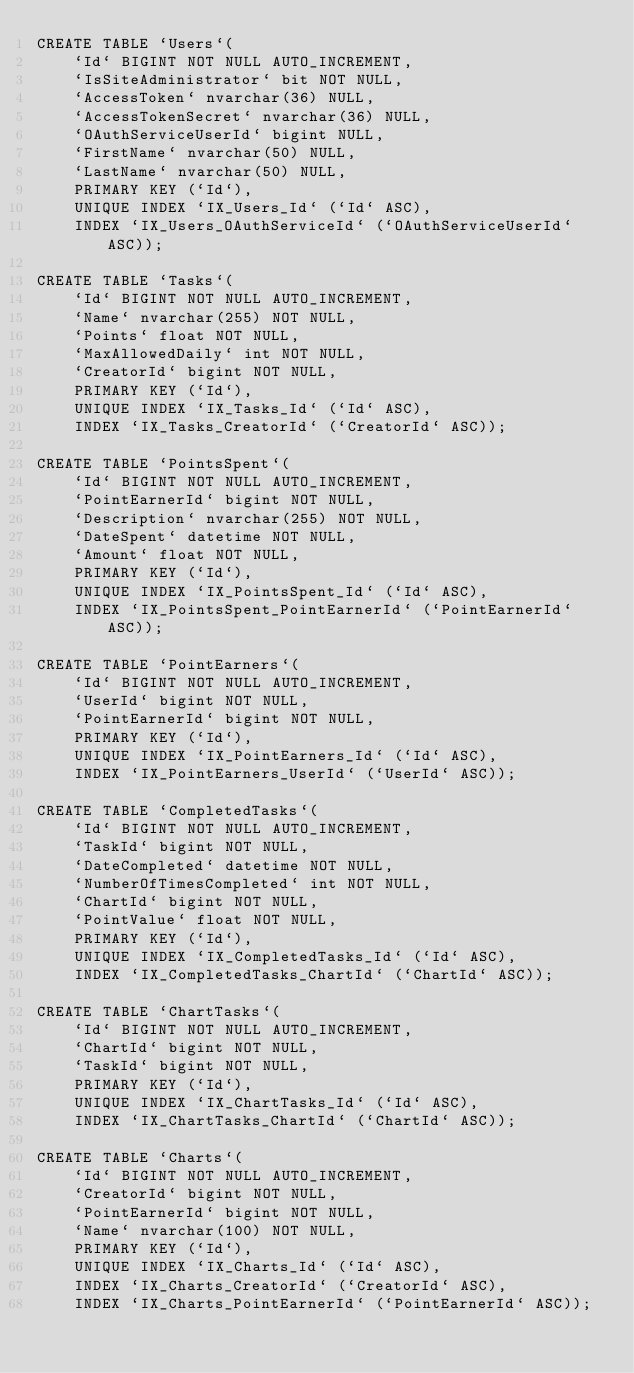<code> <loc_0><loc_0><loc_500><loc_500><_SQL_>CREATE TABLE `Users`(
	`Id` BIGINT NOT NULL AUTO_INCREMENT,
	`IsSiteAdministrator` bit NOT NULL,
	`AccessToken` nvarchar(36) NULL,
	`AccessTokenSecret` nvarchar(36) NULL,
	`OAuthServiceUserId` bigint NULL,
	`FirstName` nvarchar(50) NULL,
	`LastName` nvarchar(50) NULL,
	PRIMARY KEY (`Id`),
	UNIQUE INDEX `IX_Users_Id` (`Id` ASC),
	INDEX `IX_Users_OAuthServiceId` (`OAuthServiceUserId` ASC));

CREATE TABLE `Tasks`(
	`Id` BIGINT NOT NULL AUTO_INCREMENT,
	`Name` nvarchar(255) NOT NULL,
	`Points` float NOT NULL,
	`MaxAllowedDaily` int NOT NULL,
	`CreatorId` bigint NOT NULL,
	PRIMARY KEY (`Id`),
	UNIQUE INDEX `IX_Tasks_Id` (`Id` ASC),
	INDEX `IX_Tasks_CreatorId` (`CreatorId` ASC));

CREATE TABLE `PointsSpent`(
	`Id` BIGINT NOT NULL AUTO_INCREMENT,
	`PointEarnerId` bigint NOT NULL,
	`Description` nvarchar(255) NOT NULL,
	`DateSpent` datetime NOT NULL,
	`Amount` float NOT NULL,
	PRIMARY KEY (`Id`),
	UNIQUE INDEX `IX_PointsSpent_Id` (`Id` ASC),
	INDEX `IX_PointsSpent_PointEarnerId` (`PointEarnerId` ASC));

CREATE TABLE `PointEarners`(
	`Id` BIGINT NOT NULL AUTO_INCREMENT,
	`UserId` bigint NOT NULL,
	`PointEarnerId` bigint NOT NULL,
	PRIMARY KEY (`Id`),
	UNIQUE INDEX `IX_PointEarners_Id` (`Id` ASC),
	INDEX `IX_PointEarners_UserId` (`UserId` ASC));

CREATE TABLE `CompletedTasks`(
	`Id` BIGINT NOT NULL AUTO_INCREMENT,
	`TaskId` bigint NOT NULL,
	`DateCompleted` datetime NOT NULL,
	`NumberOfTimesCompleted` int NOT NULL,
	`ChartId` bigint NOT NULL,
	`PointValue` float NOT NULL,
	PRIMARY KEY (`Id`),
	UNIQUE INDEX `IX_CompletedTasks_Id` (`Id` ASC),
	INDEX `IX_CompletedTasks_ChartId` (`ChartId` ASC));

CREATE TABLE `ChartTasks`(
	`Id` BIGINT NOT NULL AUTO_INCREMENT,
	`ChartId` bigint NOT NULL,
	`TaskId` bigint NOT NULL,
	PRIMARY KEY (`Id`),
	UNIQUE INDEX `IX_ChartTasks_Id` (`Id` ASC),
	INDEX `IX_ChartTasks_ChartId` (`ChartId` ASC));

CREATE TABLE `Charts`(
	`Id` BIGINT NOT NULL AUTO_INCREMENT,
	`CreatorId` bigint NOT NULL,
	`PointEarnerId` bigint NOT NULL,
	`Name` nvarchar(100) NOT NULL,
	PRIMARY KEY (`Id`),
	UNIQUE INDEX `IX_Charts_Id` (`Id` ASC),
	INDEX `IX_Charts_CreatorId` (`CreatorId` ASC),
	INDEX `IX_Charts_PointEarnerId` (`PointEarnerId` ASC));
</code> 